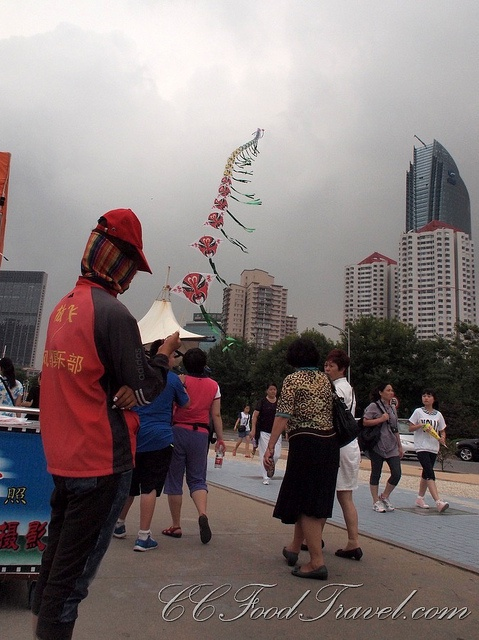Describe the objects in this image and their specific colors. I can see people in white, black, brown, and maroon tones, people in white, black, maroon, gray, and brown tones, people in white, black, maroon, and gray tones, people in white, black, navy, gray, and maroon tones, and people in white, black, gray, darkgray, and maroon tones in this image. 